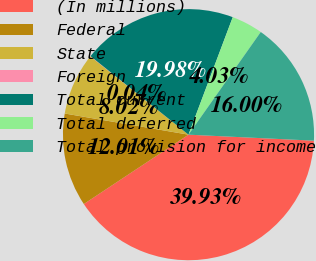Convert chart. <chart><loc_0><loc_0><loc_500><loc_500><pie_chart><fcel>(In millions)<fcel>Federal<fcel>State<fcel>Foreign<fcel>Total current<fcel>Total deferred<fcel>Total provision for income<nl><fcel>39.93%<fcel>12.01%<fcel>8.02%<fcel>0.04%<fcel>19.98%<fcel>4.03%<fcel>16.0%<nl></chart> 